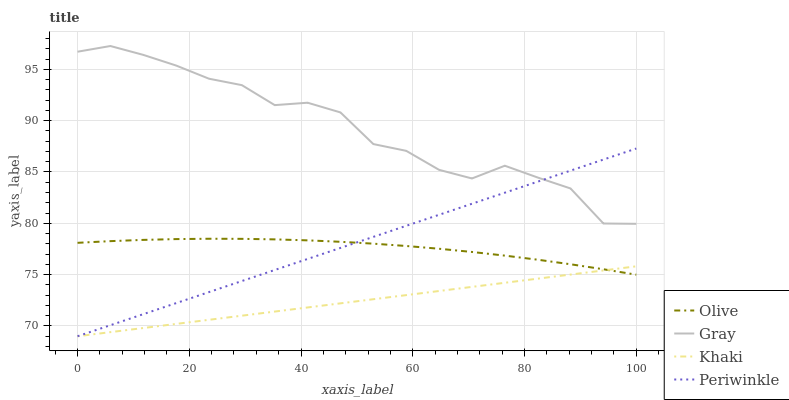Does Gray have the minimum area under the curve?
Answer yes or no. No. Does Khaki have the maximum area under the curve?
Answer yes or no. No. Is Khaki the smoothest?
Answer yes or no. No. Is Khaki the roughest?
Answer yes or no. No. Does Gray have the lowest value?
Answer yes or no. No. Does Khaki have the highest value?
Answer yes or no. No. Is Khaki less than Gray?
Answer yes or no. Yes. Is Gray greater than Khaki?
Answer yes or no. Yes. Does Khaki intersect Gray?
Answer yes or no. No. 